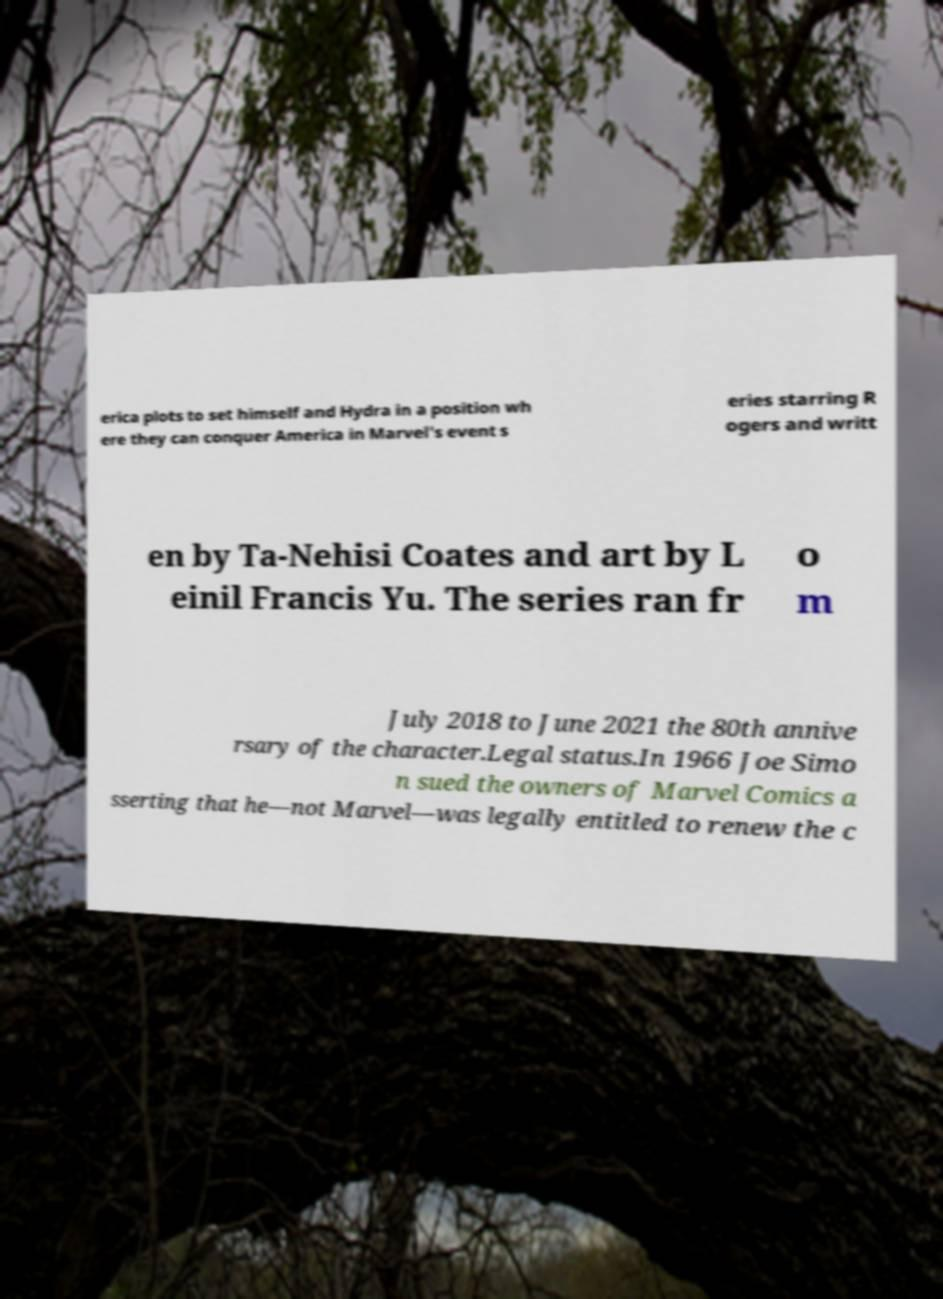Could you assist in decoding the text presented in this image and type it out clearly? erica plots to set himself and Hydra in a position wh ere they can conquer America in Marvel's event s eries starring R ogers and writt en by Ta-Nehisi Coates and art by L einil Francis Yu. The series ran fr o m July 2018 to June 2021 the 80th annive rsary of the character.Legal status.In 1966 Joe Simo n sued the owners of Marvel Comics a sserting that he—not Marvel—was legally entitled to renew the c 